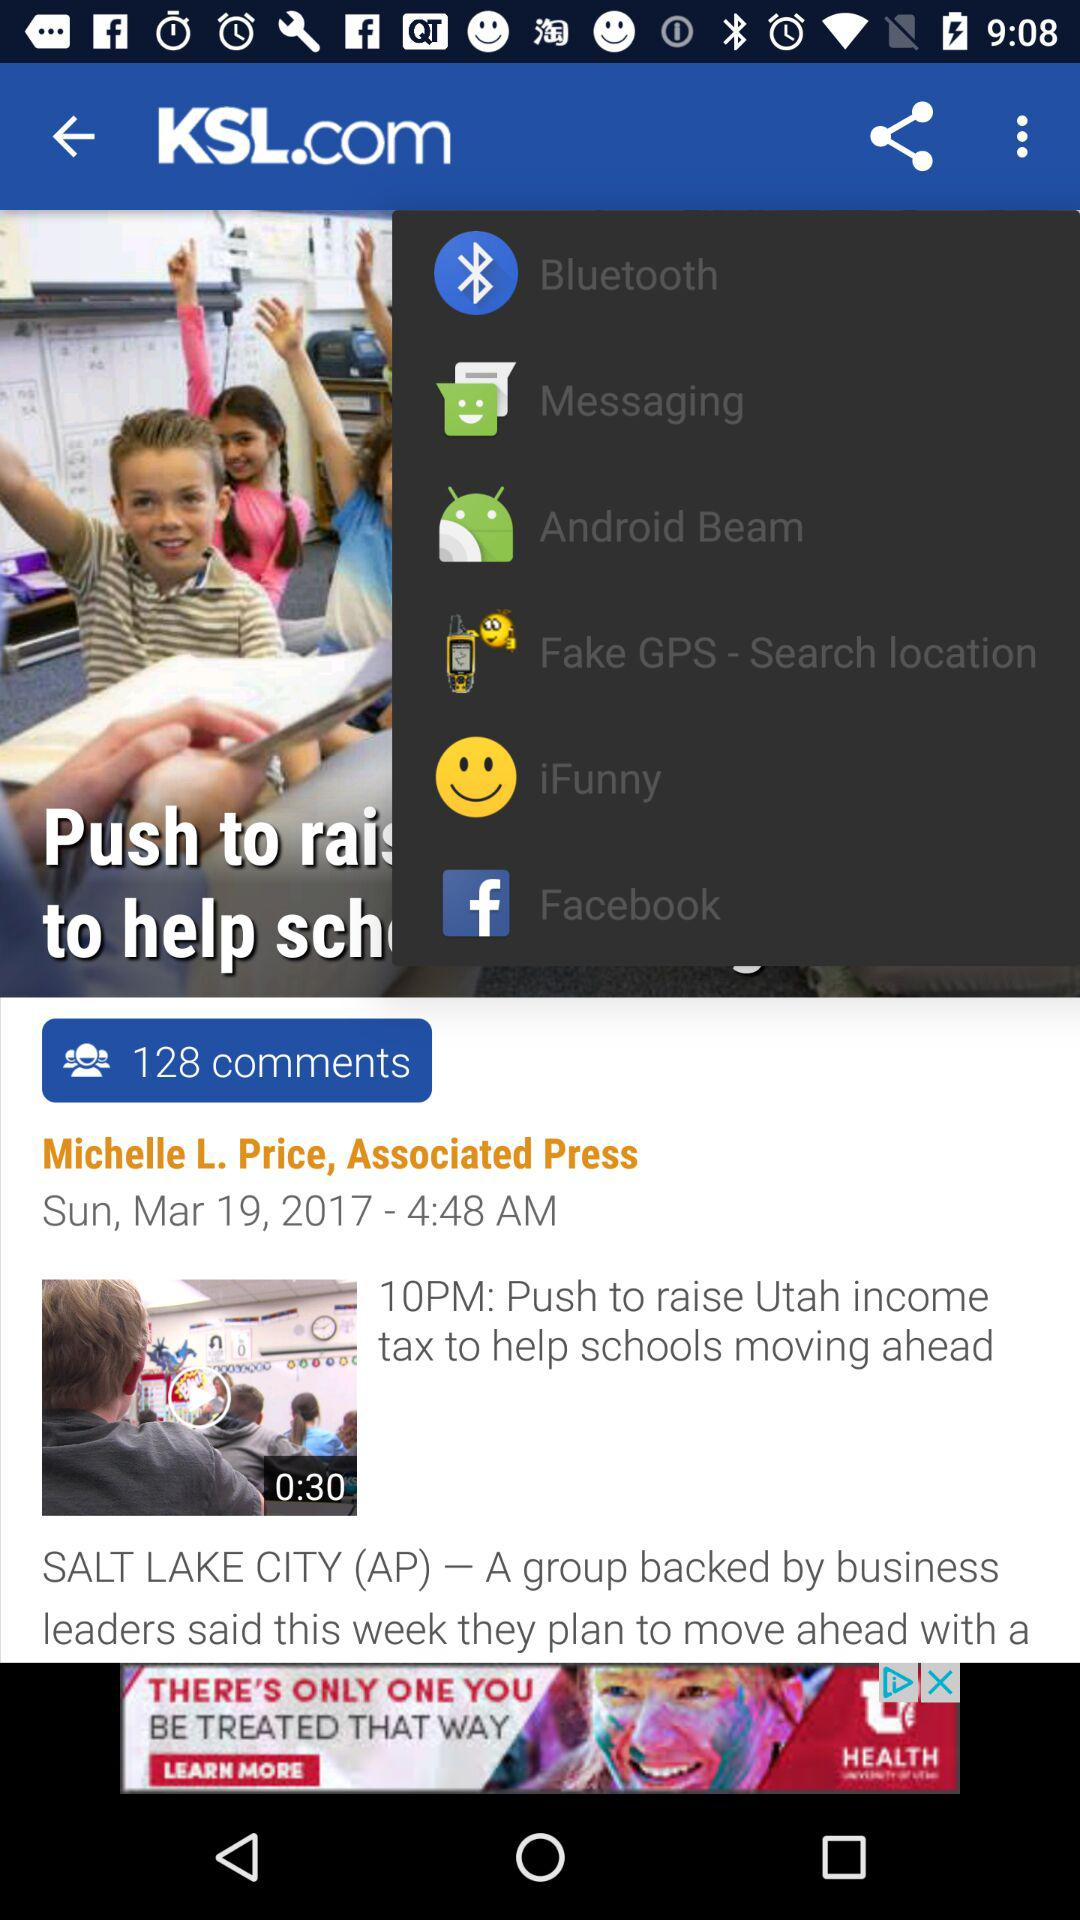Who is the author of this article? The author is Michelle L. Price. 